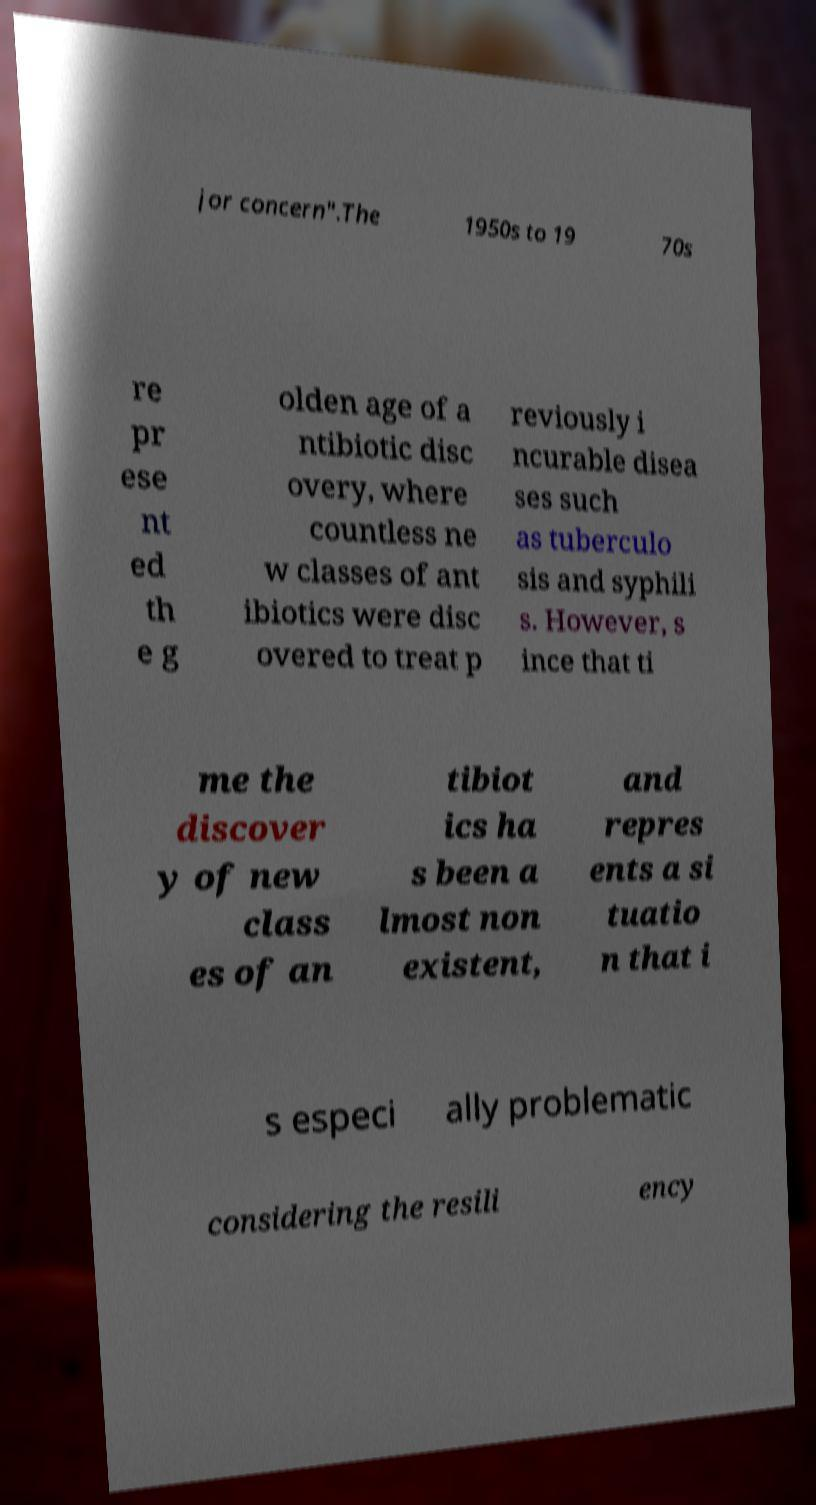Please read and relay the text visible in this image. What does it say? jor concern".The 1950s to 19 70s re pr ese nt ed th e g olden age of a ntibiotic disc overy, where countless ne w classes of ant ibiotics were disc overed to treat p reviously i ncurable disea ses such as tuberculo sis and syphili s. However, s ince that ti me the discover y of new class es of an tibiot ics ha s been a lmost non existent, and repres ents a si tuatio n that i s especi ally problematic considering the resili ency 